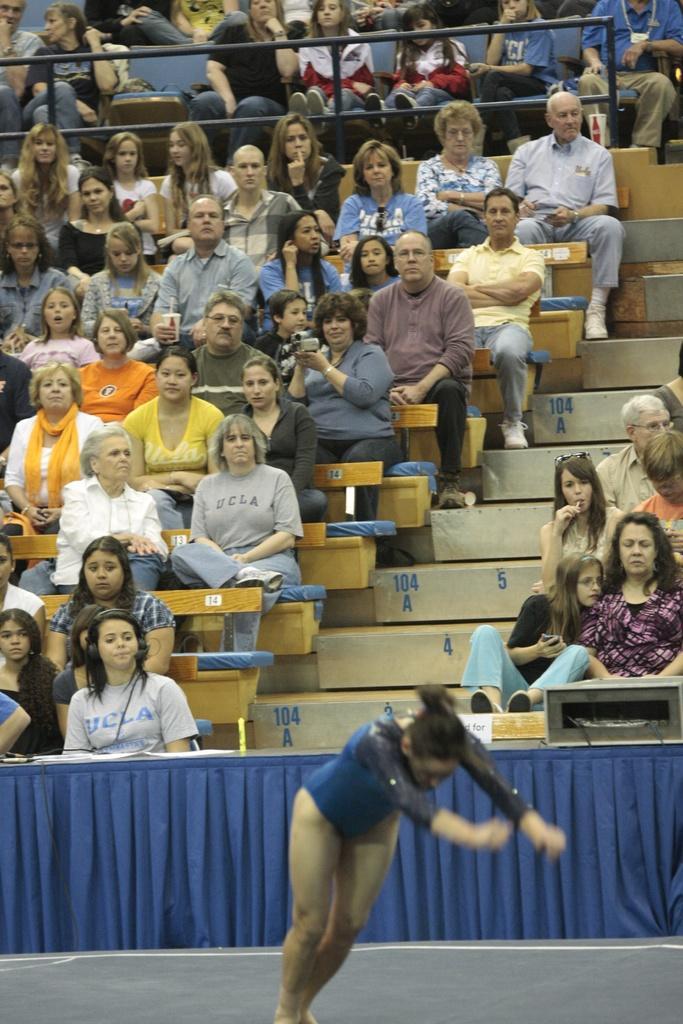Could you give a brief overview of what you see in this image? In the image there is a woman standing in the front in swimming costume, in the back there are many people sitting on benches and looking in the front. 